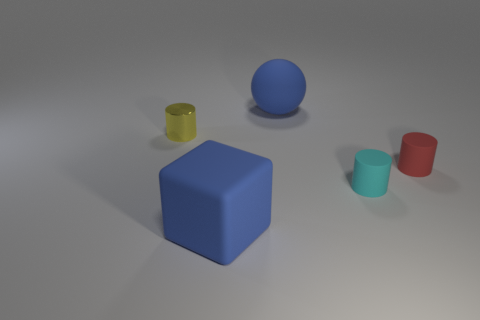Add 1 large gray metallic things. How many objects exist? 6 Subtract all cylinders. How many objects are left? 2 Subtract all small cylinders. Subtract all large green cylinders. How many objects are left? 2 Add 2 small cyan matte cylinders. How many small cyan matte cylinders are left? 3 Add 5 small cyan metal cylinders. How many small cyan metal cylinders exist? 5 Subtract 1 blue blocks. How many objects are left? 4 